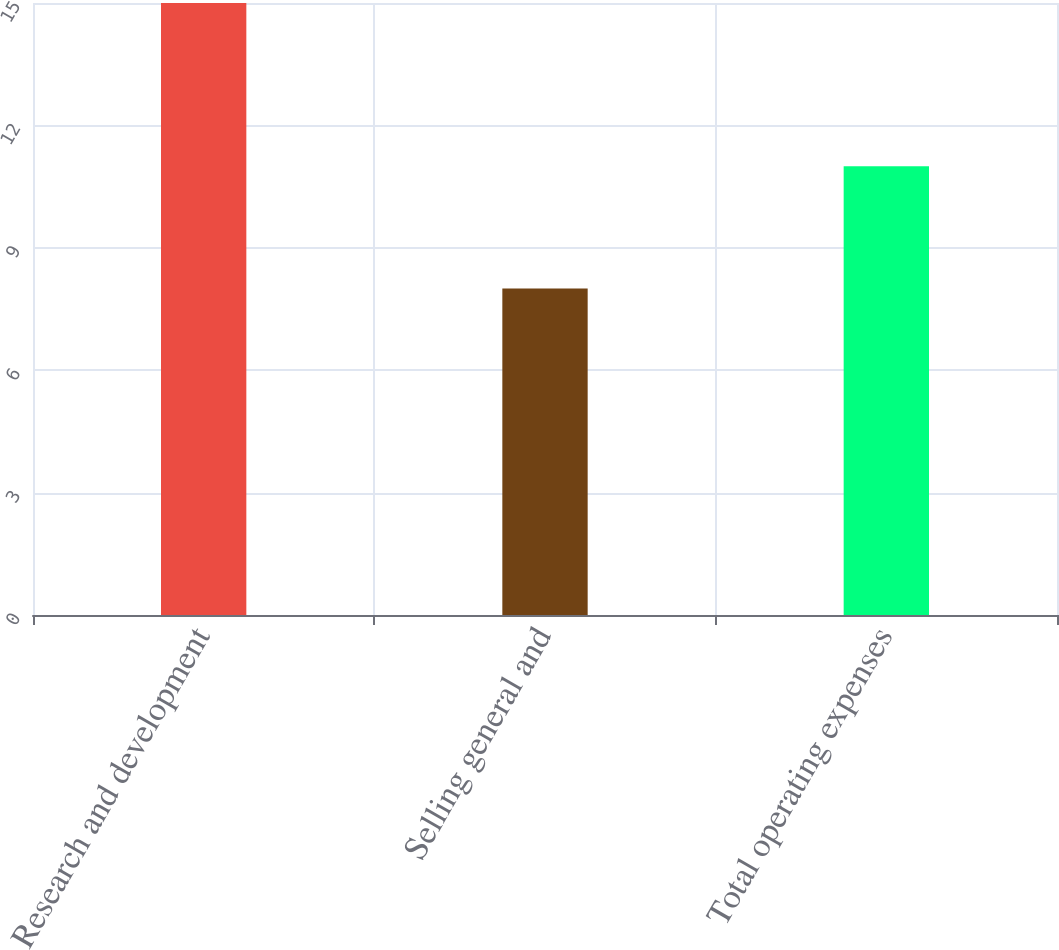<chart> <loc_0><loc_0><loc_500><loc_500><bar_chart><fcel>Research and development<fcel>Selling general and<fcel>Total operating expenses<nl><fcel>15<fcel>8<fcel>11<nl></chart> 